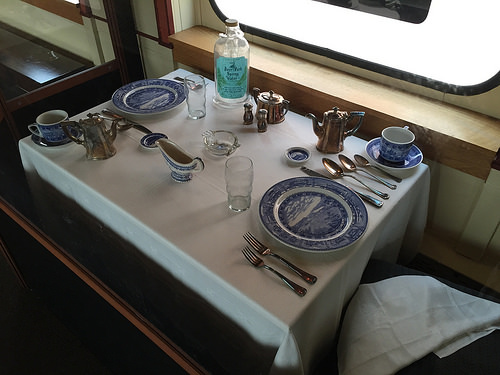<image>
Can you confirm if the glass is behind the fork? No. The glass is not behind the fork. From this viewpoint, the glass appears to be positioned elsewhere in the scene. 